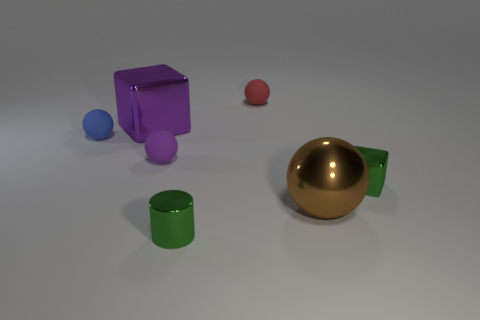Subtract all small red matte balls. How many balls are left? 3 Add 2 big purple metal blocks. How many objects exist? 9 Subtract all purple balls. How many balls are left? 3 Subtract all balls. How many objects are left? 3 Subtract 0 gray spheres. How many objects are left? 7 Subtract all blue cylinders. Subtract all brown cubes. How many cylinders are left? 1 Subtract all brown rubber cylinders. Subtract all big brown spheres. How many objects are left? 6 Add 4 purple balls. How many purple balls are left? 5 Add 5 small blue rubber cylinders. How many small blue rubber cylinders exist? 5 